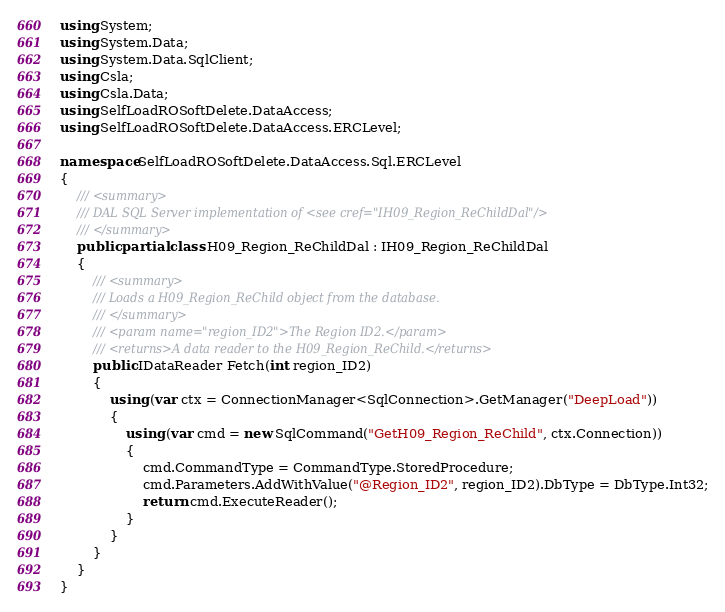Convert code to text. <code><loc_0><loc_0><loc_500><loc_500><_C#_>using System;
using System.Data;
using System.Data.SqlClient;
using Csla;
using Csla.Data;
using SelfLoadROSoftDelete.DataAccess;
using SelfLoadROSoftDelete.DataAccess.ERCLevel;

namespace SelfLoadROSoftDelete.DataAccess.Sql.ERCLevel
{
    /// <summary>
    /// DAL SQL Server implementation of <see cref="IH09_Region_ReChildDal"/>
    /// </summary>
    public partial class H09_Region_ReChildDal : IH09_Region_ReChildDal
    {
        /// <summary>
        /// Loads a H09_Region_ReChild object from the database.
        /// </summary>
        /// <param name="region_ID2">The Region ID2.</param>
        /// <returns>A data reader to the H09_Region_ReChild.</returns>
        public IDataReader Fetch(int region_ID2)
        {
            using (var ctx = ConnectionManager<SqlConnection>.GetManager("DeepLoad"))
            {
                using (var cmd = new SqlCommand("GetH09_Region_ReChild", ctx.Connection))
                {
                    cmd.CommandType = CommandType.StoredProcedure;
                    cmd.Parameters.AddWithValue("@Region_ID2", region_ID2).DbType = DbType.Int32;
                    return cmd.ExecuteReader();
                }
            }
        }
    }
}
</code> 